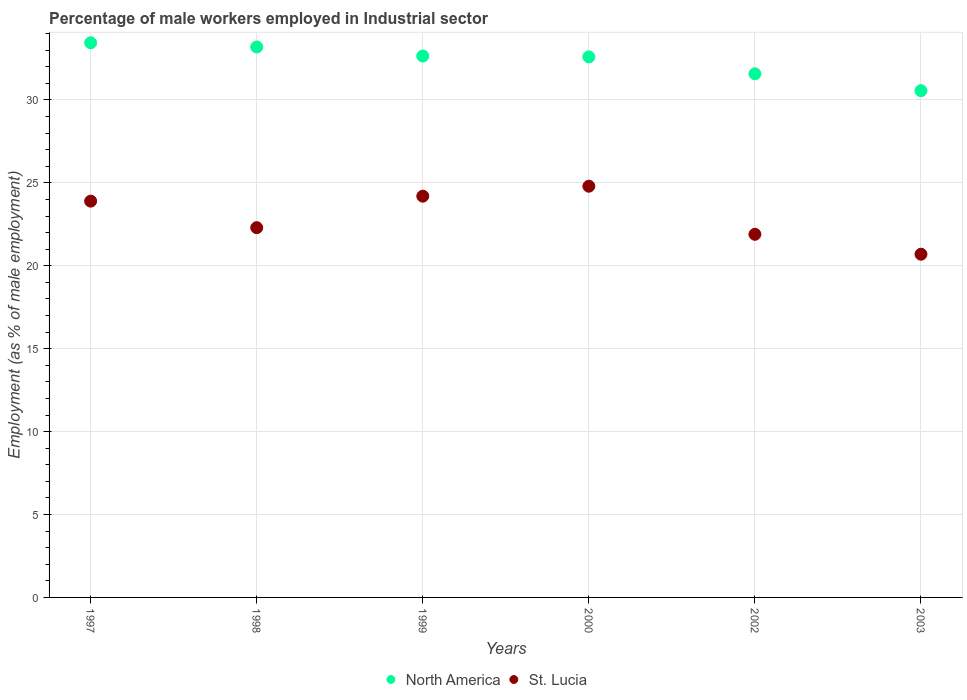Is the number of dotlines equal to the number of legend labels?
Keep it short and to the point. Yes. What is the percentage of male workers employed in Industrial sector in North America in 2002?
Your answer should be compact. 31.58. Across all years, what is the maximum percentage of male workers employed in Industrial sector in St. Lucia?
Your answer should be compact. 24.8. Across all years, what is the minimum percentage of male workers employed in Industrial sector in St. Lucia?
Offer a terse response. 20.7. In which year was the percentage of male workers employed in Industrial sector in North America maximum?
Keep it short and to the point. 1997. In which year was the percentage of male workers employed in Industrial sector in North America minimum?
Your response must be concise. 2003. What is the total percentage of male workers employed in Industrial sector in St. Lucia in the graph?
Offer a very short reply. 137.8. What is the difference between the percentage of male workers employed in Industrial sector in North America in 2000 and that in 2002?
Your answer should be compact. 1.02. What is the difference between the percentage of male workers employed in Industrial sector in North America in 2003 and the percentage of male workers employed in Industrial sector in St. Lucia in 1997?
Keep it short and to the point. 6.66. What is the average percentage of male workers employed in Industrial sector in North America per year?
Your response must be concise. 32.34. In the year 2002, what is the difference between the percentage of male workers employed in Industrial sector in North America and percentage of male workers employed in Industrial sector in St. Lucia?
Your answer should be very brief. 9.68. What is the ratio of the percentage of male workers employed in Industrial sector in North America in 1997 to that in 2002?
Provide a succinct answer. 1.06. Is the percentage of male workers employed in Industrial sector in St. Lucia in 1997 less than that in 2002?
Offer a terse response. No. What is the difference between the highest and the second highest percentage of male workers employed in Industrial sector in St. Lucia?
Offer a terse response. 0.6. What is the difference between the highest and the lowest percentage of male workers employed in Industrial sector in St. Lucia?
Make the answer very short. 4.1. In how many years, is the percentage of male workers employed in Industrial sector in St. Lucia greater than the average percentage of male workers employed in Industrial sector in St. Lucia taken over all years?
Give a very brief answer. 3. Is the sum of the percentage of male workers employed in Industrial sector in North America in 1998 and 2000 greater than the maximum percentage of male workers employed in Industrial sector in St. Lucia across all years?
Offer a terse response. Yes. Is the percentage of male workers employed in Industrial sector in St. Lucia strictly greater than the percentage of male workers employed in Industrial sector in North America over the years?
Provide a short and direct response. No. Is the percentage of male workers employed in Industrial sector in North America strictly less than the percentage of male workers employed in Industrial sector in St. Lucia over the years?
Offer a terse response. No. How many dotlines are there?
Give a very brief answer. 2. How many years are there in the graph?
Offer a very short reply. 6. What is the difference between two consecutive major ticks on the Y-axis?
Provide a short and direct response. 5. Does the graph contain grids?
Offer a very short reply. Yes. Where does the legend appear in the graph?
Ensure brevity in your answer.  Bottom center. How are the legend labels stacked?
Provide a succinct answer. Horizontal. What is the title of the graph?
Make the answer very short. Percentage of male workers employed in Industrial sector. What is the label or title of the Y-axis?
Provide a short and direct response. Employment (as % of male employment). What is the Employment (as % of male employment) in North America in 1997?
Your answer should be compact. 33.45. What is the Employment (as % of male employment) of St. Lucia in 1997?
Keep it short and to the point. 23.9. What is the Employment (as % of male employment) in North America in 1998?
Your response must be concise. 33.2. What is the Employment (as % of male employment) in St. Lucia in 1998?
Make the answer very short. 22.3. What is the Employment (as % of male employment) of North America in 1999?
Keep it short and to the point. 32.65. What is the Employment (as % of male employment) in St. Lucia in 1999?
Give a very brief answer. 24.2. What is the Employment (as % of male employment) in North America in 2000?
Your response must be concise. 32.6. What is the Employment (as % of male employment) in St. Lucia in 2000?
Your response must be concise. 24.8. What is the Employment (as % of male employment) of North America in 2002?
Offer a very short reply. 31.58. What is the Employment (as % of male employment) of St. Lucia in 2002?
Your answer should be very brief. 21.9. What is the Employment (as % of male employment) in North America in 2003?
Your answer should be compact. 30.56. What is the Employment (as % of male employment) of St. Lucia in 2003?
Make the answer very short. 20.7. Across all years, what is the maximum Employment (as % of male employment) in North America?
Give a very brief answer. 33.45. Across all years, what is the maximum Employment (as % of male employment) in St. Lucia?
Make the answer very short. 24.8. Across all years, what is the minimum Employment (as % of male employment) in North America?
Keep it short and to the point. 30.56. Across all years, what is the minimum Employment (as % of male employment) of St. Lucia?
Offer a terse response. 20.7. What is the total Employment (as % of male employment) in North America in the graph?
Provide a short and direct response. 194.04. What is the total Employment (as % of male employment) of St. Lucia in the graph?
Give a very brief answer. 137.8. What is the difference between the Employment (as % of male employment) of North America in 1997 and that in 1998?
Provide a short and direct response. 0.25. What is the difference between the Employment (as % of male employment) in St. Lucia in 1997 and that in 1998?
Ensure brevity in your answer.  1.6. What is the difference between the Employment (as % of male employment) of North America in 1997 and that in 1999?
Provide a short and direct response. 0.8. What is the difference between the Employment (as % of male employment) of North America in 1997 and that in 2000?
Offer a terse response. 0.85. What is the difference between the Employment (as % of male employment) of North America in 1997 and that in 2002?
Your response must be concise. 1.87. What is the difference between the Employment (as % of male employment) in North America in 1997 and that in 2003?
Give a very brief answer. 2.89. What is the difference between the Employment (as % of male employment) of North America in 1998 and that in 1999?
Provide a succinct answer. 0.54. What is the difference between the Employment (as % of male employment) of North America in 1998 and that in 2000?
Offer a very short reply. 0.6. What is the difference between the Employment (as % of male employment) in St. Lucia in 1998 and that in 2000?
Offer a very short reply. -2.5. What is the difference between the Employment (as % of male employment) in North America in 1998 and that in 2002?
Your response must be concise. 1.62. What is the difference between the Employment (as % of male employment) of St. Lucia in 1998 and that in 2002?
Give a very brief answer. 0.4. What is the difference between the Employment (as % of male employment) of North America in 1998 and that in 2003?
Offer a very short reply. 2.63. What is the difference between the Employment (as % of male employment) in St. Lucia in 1998 and that in 2003?
Offer a very short reply. 1.6. What is the difference between the Employment (as % of male employment) of North America in 1999 and that in 2000?
Keep it short and to the point. 0.05. What is the difference between the Employment (as % of male employment) of St. Lucia in 1999 and that in 2000?
Make the answer very short. -0.6. What is the difference between the Employment (as % of male employment) of North America in 1999 and that in 2002?
Offer a terse response. 1.07. What is the difference between the Employment (as % of male employment) of St. Lucia in 1999 and that in 2002?
Give a very brief answer. 2.3. What is the difference between the Employment (as % of male employment) in North America in 1999 and that in 2003?
Ensure brevity in your answer.  2.09. What is the difference between the Employment (as % of male employment) in St. Lucia in 1999 and that in 2003?
Offer a terse response. 3.5. What is the difference between the Employment (as % of male employment) of North America in 2000 and that in 2002?
Offer a terse response. 1.02. What is the difference between the Employment (as % of male employment) of St. Lucia in 2000 and that in 2002?
Make the answer very short. 2.9. What is the difference between the Employment (as % of male employment) in North America in 2000 and that in 2003?
Your response must be concise. 2.04. What is the difference between the Employment (as % of male employment) in North America in 2002 and that in 2003?
Provide a succinct answer. 1.02. What is the difference between the Employment (as % of male employment) of St. Lucia in 2002 and that in 2003?
Your response must be concise. 1.2. What is the difference between the Employment (as % of male employment) of North America in 1997 and the Employment (as % of male employment) of St. Lucia in 1998?
Offer a very short reply. 11.15. What is the difference between the Employment (as % of male employment) in North America in 1997 and the Employment (as % of male employment) in St. Lucia in 1999?
Provide a succinct answer. 9.25. What is the difference between the Employment (as % of male employment) in North America in 1997 and the Employment (as % of male employment) in St. Lucia in 2000?
Your answer should be very brief. 8.65. What is the difference between the Employment (as % of male employment) of North America in 1997 and the Employment (as % of male employment) of St. Lucia in 2002?
Your answer should be compact. 11.55. What is the difference between the Employment (as % of male employment) of North America in 1997 and the Employment (as % of male employment) of St. Lucia in 2003?
Offer a terse response. 12.75. What is the difference between the Employment (as % of male employment) of North America in 1998 and the Employment (as % of male employment) of St. Lucia in 1999?
Give a very brief answer. 9. What is the difference between the Employment (as % of male employment) of North America in 1998 and the Employment (as % of male employment) of St. Lucia in 2000?
Your answer should be compact. 8.4. What is the difference between the Employment (as % of male employment) in North America in 1998 and the Employment (as % of male employment) in St. Lucia in 2002?
Make the answer very short. 11.3. What is the difference between the Employment (as % of male employment) in North America in 1998 and the Employment (as % of male employment) in St. Lucia in 2003?
Your answer should be compact. 12.5. What is the difference between the Employment (as % of male employment) in North America in 1999 and the Employment (as % of male employment) in St. Lucia in 2000?
Ensure brevity in your answer.  7.85. What is the difference between the Employment (as % of male employment) in North America in 1999 and the Employment (as % of male employment) in St. Lucia in 2002?
Your answer should be very brief. 10.75. What is the difference between the Employment (as % of male employment) in North America in 1999 and the Employment (as % of male employment) in St. Lucia in 2003?
Ensure brevity in your answer.  11.95. What is the difference between the Employment (as % of male employment) of North America in 2000 and the Employment (as % of male employment) of St. Lucia in 2003?
Give a very brief answer. 11.9. What is the difference between the Employment (as % of male employment) of North America in 2002 and the Employment (as % of male employment) of St. Lucia in 2003?
Offer a terse response. 10.88. What is the average Employment (as % of male employment) in North America per year?
Keep it short and to the point. 32.34. What is the average Employment (as % of male employment) in St. Lucia per year?
Your response must be concise. 22.97. In the year 1997, what is the difference between the Employment (as % of male employment) of North America and Employment (as % of male employment) of St. Lucia?
Provide a succinct answer. 9.55. In the year 1998, what is the difference between the Employment (as % of male employment) in North America and Employment (as % of male employment) in St. Lucia?
Ensure brevity in your answer.  10.9. In the year 1999, what is the difference between the Employment (as % of male employment) in North America and Employment (as % of male employment) in St. Lucia?
Provide a succinct answer. 8.45. In the year 2002, what is the difference between the Employment (as % of male employment) of North America and Employment (as % of male employment) of St. Lucia?
Ensure brevity in your answer.  9.68. In the year 2003, what is the difference between the Employment (as % of male employment) in North America and Employment (as % of male employment) in St. Lucia?
Provide a short and direct response. 9.86. What is the ratio of the Employment (as % of male employment) in North America in 1997 to that in 1998?
Your response must be concise. 1.01. What is the ratio of the Employment (as % of male employment) in St. Lucia in 1997 to that in 1998?
Your answer should be compact. 1.07. What is the ratio of the Employment (as % of male employment) in North America in 1997 to that in 1999?
Your answer should be very brief. 1.02. What is the ratio of the Employment (as % of male employment) in St. Lucia in 1997 to that in 1999?
Make the answer very short. 0.99. What is the ratio of the Employment (as % of male employment) in St. Lucia in 1997 to that in 2000?
Ensure brevity in your answer.  0.96. What is the ratio of the Employment (as % of male employment) of North America in 1997 to that in 2002?
Offer a terse response. 1.06. What is the ratio of the Employment (as % of male employment) of St. Lucia in 1997 to that in 2002?
Make the answer very short. 1.09. What is the ratio of the Employment (as % of male employment) of North America in 1997 to that in 2003?
Offer a very short reply. 1.09. What is the ratio of the Employment (as % of male employment) in St. Lucia in 1997 to that in 2003?
Keep it short and to the point. 1.15. What is the ratio of the Employment (as % of male employment) of North America in 1998 to that in 1999?
Provide a succinct answer. 1.02. What is the ratio of the Employment (as % of male employment) in St. Lucia in 1998 to that in 1999?
Your answer should be compact. 0.92. What is the ratio of the Employment (as % of male employment) in North America in 1998 to that in 2000?
Your response must be concise. 1.02. What is the ratio of the Employment (as % of male employment) in St. Lucia in 1998 to that in 2000?
Offer a terse response. 0.9. What is the ratio of the Employment (as % of male employment) in North America in 1998 to that in 2002?
Offer a very short reply. 1.05. What is the ratio of the Employment (as % of male employment) in St. Lucia in 1998 to that in 2002?
Make the answer very short. 1.02. What is the ratio of the Employment (as % of male employment) in North America in 1998 to that in 2003?
Ensure brevity in your answer.  1.09. What is the ratio of the Employment (as % of male employment) of St. Lucia in 1998 to that in 2003?
Your answer should be compact. 1.08. What is the ratio of the Employment (as % of male employment) of North America in 1999 to that in 2000?
Offer a very short reply. 1. What is the ratio of the Employment (as % of male employment) in St. Lucia in 1999 to that in 2000?
Keep it short and to the point. 0.98. What is the ratio of the Employment (as % of male employment) in North America in 1999 to that in 2002?
Your answer should be compact. 1.03. What is the ratio of the Employment (as % of male employment) in St. Lucia in 1999 to that in 2002?
Your answer should be very brief. 1.1. What is the ratio of the Employment (as % of male employment) in North America in 1999 to that in 2003?
Keep it short and to the point. 1.07. What is the ratio of the Employment (as % of male employment) in St. Lucia in 1999 to that in 2003?
Provide a short and direct response. 1.17. What is the ratio of the Employment (as % of male employment) in North America in 2000 to that in 2002?
Your response must be concise. 1.03. What is the ratio of the Employment (as % of male employment) in St. Lucia in 2000 to that in 2002?
Provide a succinct answer. 1.13. What is the ratio of the Employment (as % of male employment) of North America in 2000 to that in 2003?
Provide a succinct answer. 1.07. What is the ratio of the Employment (as % of male employment) of St. Lucia in 2000 to that in 2003?
Ensure brevity in your answer.  1.2. What is the ratio of the Employment (as % of male employment) in North America in 2002 to that in 2003?
Keep it short and to the point. 1.03. What is the ratio of the Employment (as % of male employment) of St. Lucia in 2002 to that in 2003?
Your answer should be very brief. 1.06. What is the difference between the highest and the second highest Employment (as % of male employment) in North America?
Your answer should be compact. 0.25. What is the difference between the highest and the lowest Employment (as % of male employment) in North America?
Make the answer very short. 2.89. What is the difference between the highest and the lowest Employment (as % of male employment) of St. Lucia?
Offer a very short reply. 4.1. 